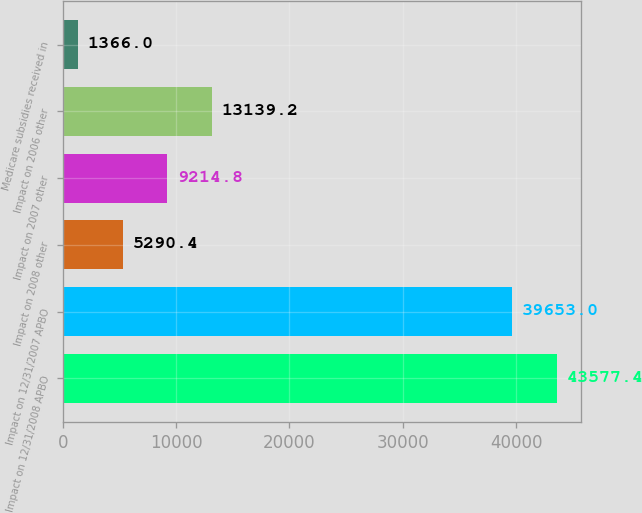Convert chart. <chart><loc_0><loc_0><loc_500><loc_500><bar_chart><fcel>Impact on 12/31/2008 APBO<fcel>Impact on 12/31/2007 APBO<fcel>Impact on 2008 other<fcel>Impact on 2007 other<fcel>Impact on 2006 other<fcel>Medicare subsidies received in<nl><fcel>43577.4<fcel>39653<fcel>5290.4<fcel>9214.8<fcel>13139.2<fcel>1366<nl></chart> 